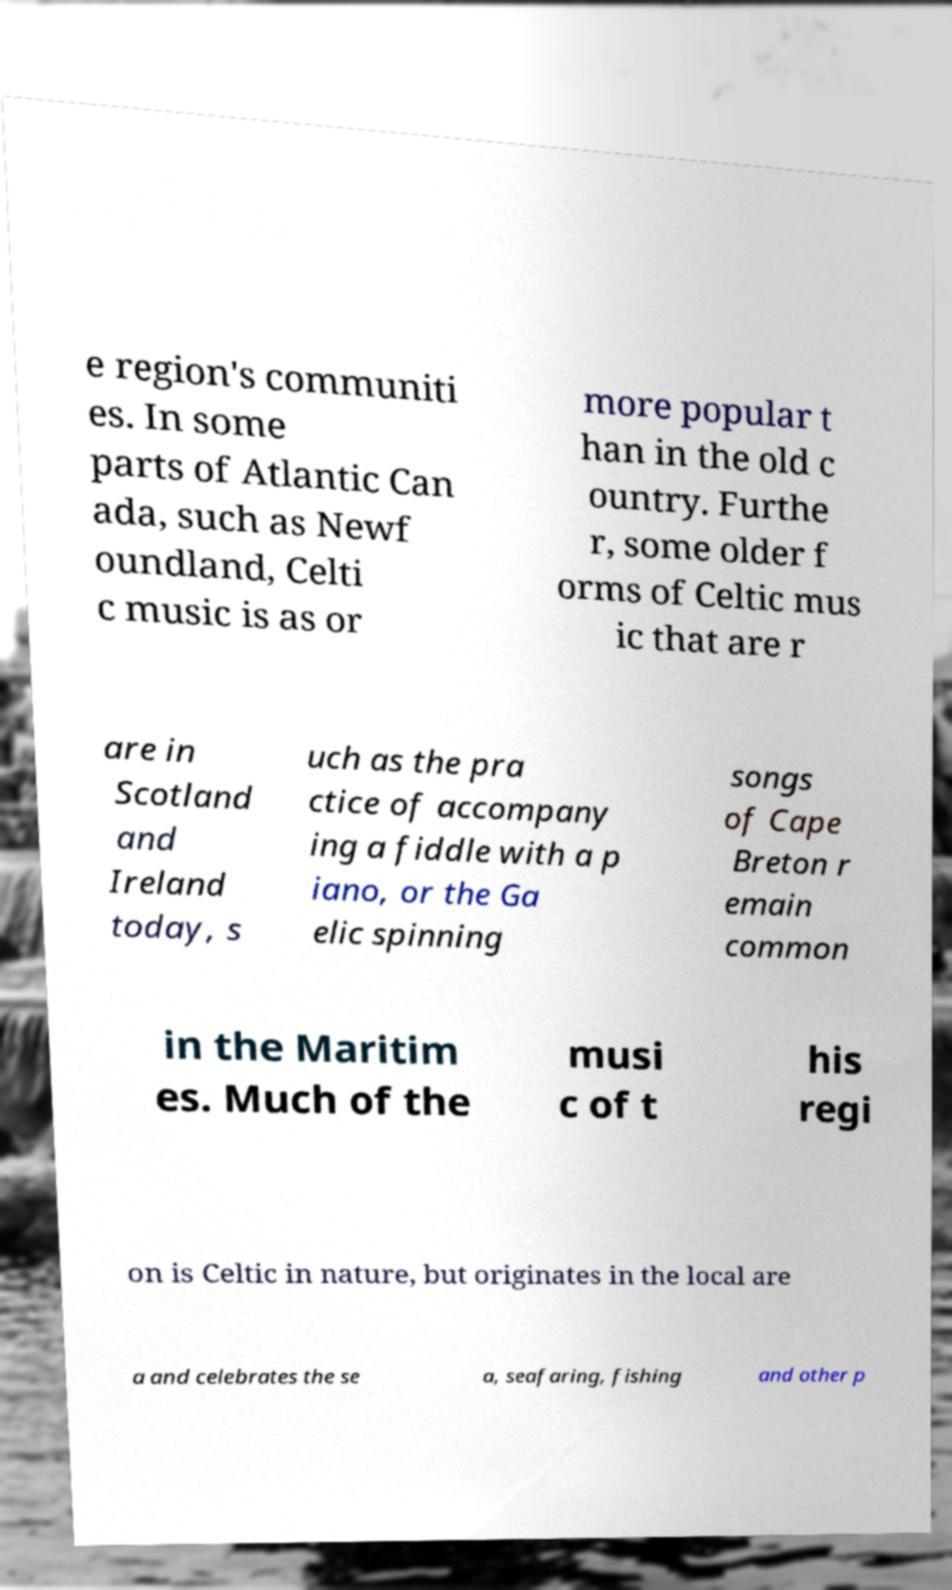I need the written content from this picture converted into text. Can you do that? e region's communiti es. In some parts of Atlantic Can ada, such as Newf oundland, Celti c music is as or more popular t han in the old c ountry. Furthe r, some older f orms of Celtic mus ic that are r are in Scotland and Ireland today, s uch as the pra ctice of accompany ing a fiddle with a p iano, or the Ga elic spinning songs of Cape Breton r emain common in the Maritim es. Much of the musi c of t his regi on is Celtic in nature, but originates in the local are a and celebrates the se a, seafaring, fishing and other p 